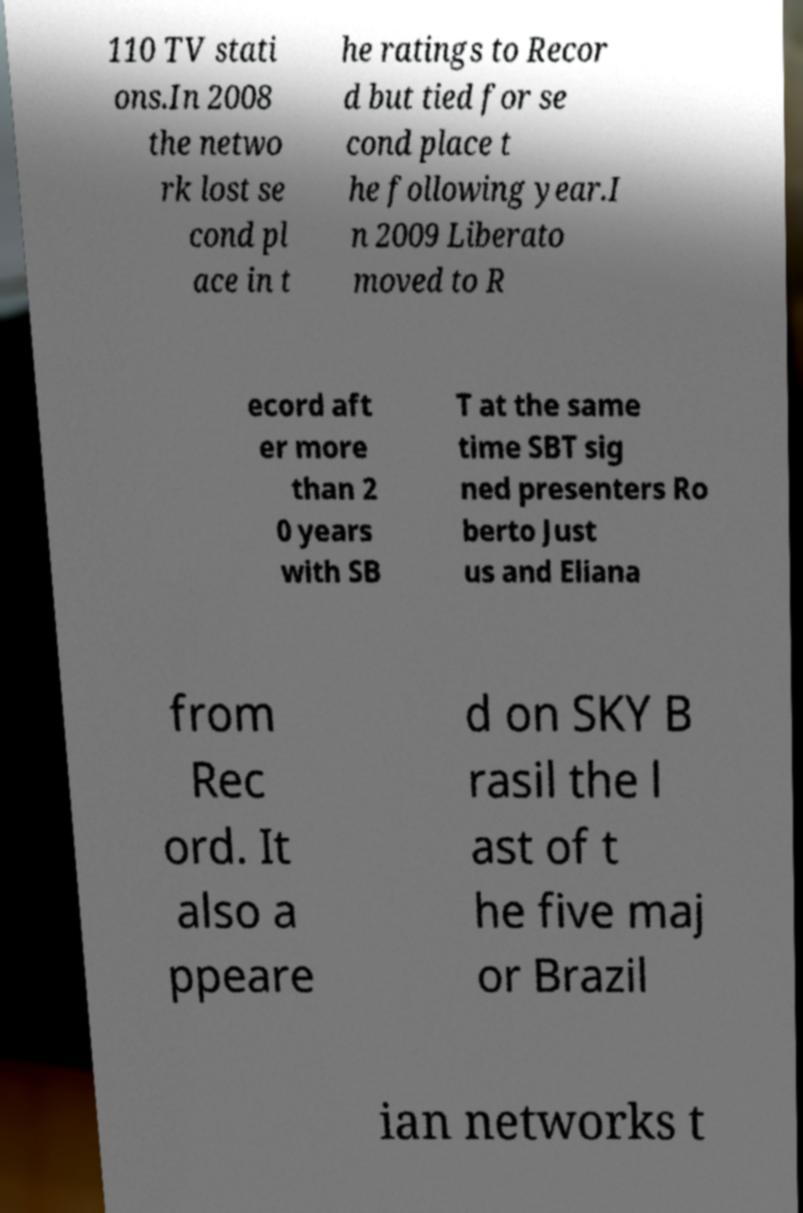Please read and relay the text visible in this image. What does it say? 110 TV stati ons.In 2008 the netwo rk lost se cond pl ace in t he ratings to Recor d but tied for se cond place t he following year.I n 2009 Liberato moved to R ecord aft er more than 2 0 years with SB T at the same time SBT sig ned presenters Ro berto Just us and Eliana from Rec ord. It also a ppeare d on SKY B rasil the l ast of t he five maj or Brazil ian networks t 